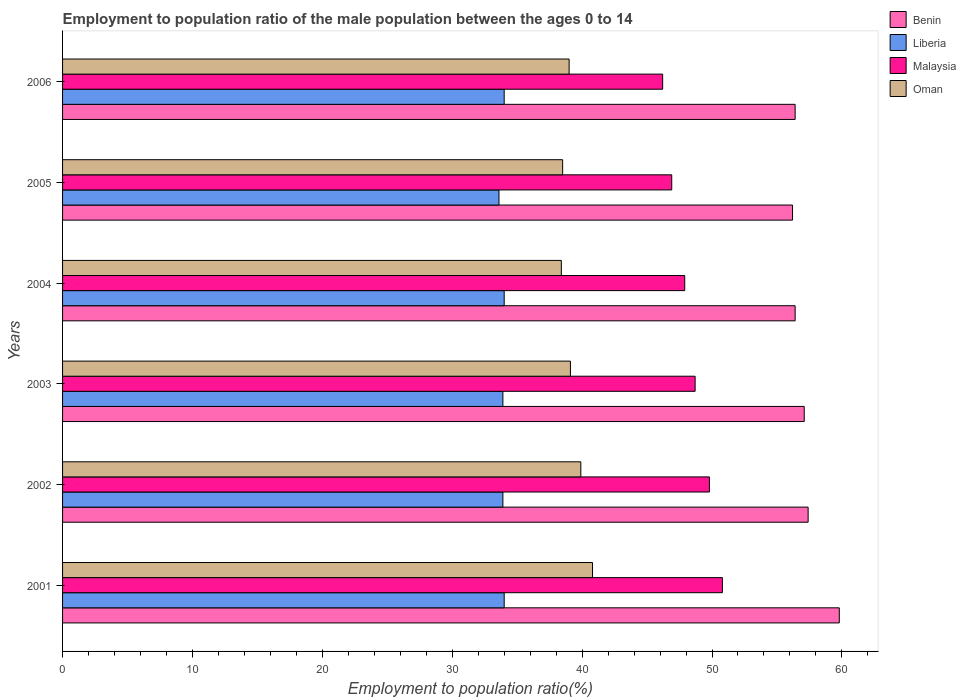How many different coloured bars are there?
Ensure brevity in your answer.  4. Are the number of bars on each tick of the Y-axis equal?
Ensure brevity in your answer.  Yes. In how many cases, is the number of bars for a given year not equal to the number of legend labels?
Give a very brief answer. 0. What is the employment to population ratio in Malaysia in 2001?
Offer a very short reply. 50.8. Across all years, what is the maximum employment to population ratio in Benin?
Keep it short and to the point. 59.8. Across all years, what is the minimum employment to population ratio in Malaysia?
Offer a very short reply. 46.2. In which year was the employment to population ratio in Malaysia maximum?
Provide a short and direct response. 2001. What is the total employment to population ratio in Liberia in the graph?
Give a very brief answer. 203.4. What is the difference between the employment to population ratio in Malaysia in 2001 and that in 2004?
Provide a short and direct response. 2.9. What is the difference between the employment to population ratio in Benin in 2004 and the employment to population ratio in Oman in 2005?
Your response must be concise. 17.9. What is the average employment to population ratio in Oman per year?
Ensure brevity in your answer.  39.28. In the year 2004, what is the difference between the employment to population ratio in Malaysia and employment to population ratio in Liberia?
Offer a very short reply. 13.9. In how many years, is the employment to population ratio in Liberia greater than 54 %?
Offer a terse response. 0. What is the ratio of the employment to population ratio in Oman in 2002 to that in 2005?
Give a very brief answer. 1.04. Is the employment to population ratio in Oman in 2003 less than that in 2006?
Provide a short and direct response. No. Is the difference between the employment to population ratio in Malaysia in 2003 and 2004 greater than the difference between the employment to population ratio in Liberia in 2003 and 2004?
Ensure brevity in your answer.  Yes. What is the difference between the highest and the lowest employment to population ratio in Benin?
Keep it short and to the point. 3.6. What does the 4th bar from the top in 2004 represents?
Give a very brief answer. Benin. What does the 2nd bar from the bottom in 2005 represents?
Offer a very short reply. Liberia. How many years are there in the graph?
Offer a very short reply. 6. What is the difference between two consecutive major ticks on the X-axis?
Offer a terse response. 10. Are the values on the major ticks of X-axis written in scientific E-notation?
Offer a very short reply. No. Does the graph contain grids?
Keep it short and to the point. No. What is the title of the graph?
Ensure brevity in your answer.  Employment to population ratio of the male population between the ages 0 to 14. What is the Employment to population ratio(%) of Benin in 2001?
Offer a terse response. 59.8. What is the Employment to population ratio(%) of Liberia in 2001?
Give a very brief answer. 34. What is the Employment to population ratio(%) of Malaysia in 2001?
Keep it short and to the point. 50.8. What is the Employment to population ratio(%) in Oman in 2001?
Provide a short and direct response. 40.8. What is the Employment to population ratio(%) of Benin in 2002?
Offer a terse response. 57.4. What is the Employment to population ratio(%) in Liberia in 2002?
Provide a succinct answer. 33.9. What is the Employment to population ratio(%) of Malaysia in 2002?
Provide a short and direct response. 49.8. What is the Employment to population ratio(%) of Oman in 2002?
Your response must be concise. 39.9. What is the Employment to population ratio(%) in Benin in 2003?
Keep it short and to the point. 57.1. What is the Employment to population ratio(%) of Liberia in 2003?
Provide a short and direct response. 33.9. What is the Employment to population ratio(%) in Malaysia in 2003?
Keep it short and to the point. 48.7. What is the Employment to population ratio(%) in Oman in 2003?
Offer a terse response. 39.1. What is the Employment to population ratio(%) in Benin in 2004?
Ensure brevity in your answer.  56.4. What is the Employment to population ratio(%) of Liberia in 2004?
Your response must be concise. 34. What is the Employment to population ratio(%) of Malaysia in 2004?
Make the answer very short. 47.9. What is the Employment to population ratio(%) in Oman in 2004?
Provide a succinct answer. 38.4. What is the Employment to population ratio(%) in Benin in 2005?
Your answer should be compact. 56.2. What is the Employment to population ratio(%) in Liberia in 2005?
Make the answer very short. 33.6. What is the Employment to population ratio(%) in Malaysia in 2005?
Keep it short and to the point. 46.9. What is the Employment to population ratio(%) of Oman in 2005?
Provide a succinct answer. 38.5. What is the Employment to population ratio(%) of Benin in 2006?
Provide a short and direct response. 56.4. What is the Employment to population ratio(%) in Malaysia in 2006?
Ensure brevity in your answer.  46.2. What is the Employment to population ratio(%) of Oman in 2006?
Provide a succinct answer. 39. Across all years, what is the maximum Employment to population ratio(%) in Benin?
Offer a terse response. 59.8. Across all years, what is the maximum Employment to population ratio(%) in Liberia?
Give a very brief answer. 34. Across all years, what is the maximum Employment to population ratio(%) of Malaysia?
Make the answer very short. 50.8. Across all years, what is the maximum Employment to population ratio(%) of Oman?
Make the answer very short. 40.8. Across all years, what is the minimum Employment to population ratio(%) of Benin?
Offer a very short reply. 56.2. Across all years, what is the minimum Employment to population ratio(%) in Liberia?
Keep it short and to the point. 33.6. Across all years, what is the minimum Employment to population ratio(%) of Malaysia?
Keep it short and to the point. 46.2. Across all years, what is the minimum Employment to population ratio(%) in Oman?
Your answer should be very brief. 38.4. What is the total Employment to population ratio(%) of Benin in the graph?
Offer a terse response. 343.3. What is the total Employment to population ratio(%) in Liberia in the graph?
Provide a short and direct response. 203.4. What is the total Employment to population ratio(%) of Malaysia in the graph?
Your answer should be compact. 290.3. What is the total Employment to population ratio(%) in Oman in the graph?
Offer a terse response. 235.7. What is the difference between the Employment to population ratio(%) in Benin in 2001 and that in 2002?
Offer a very short reply. 2.4. What is the difference between the Employment to population ratio(%) in Liberia in 2001 and that in 2002?
Offer a terse response. 0.1. What is the difference between the Employment to population ratio(%) of Oman in 2001 and that in 2002?
Your answer should be very brief. 0.9. What is the difference between the Employment to population ratio(%) in Benin in 2001 and that in 2003?
Offer a very short reply. 2.7. What is the difference between the Employment to population ratio(%) in Liberia in 2001 and that in 2003?
Provide a succinct answer. 0.1. What is the difference between the Employment to population ratio(%) of Malaysia in 2001 and that in 2003?
Your answer should be compact. 2.1. What is the difference between the Employment to population ratio(%) in Oman in 2001 and that in 2003?
Keep it short and to the point. 1.7. What is the difference between the Employment to population ratio(%) in Liberia in 2001 and that in 2004?
Offer a very short reply. 0. What is the difference between the Employment to population ratio(%) of Oman in 2001 and that in 2004?
Offer a terse response. 2.4. What is the difference between the Employment to population ratio(%) in Benin in 2001 and that in 2005?
Your response must be concise. 3.6. What is the difference between the Employment to population ratio(%) of Oman in 2001 and that in 2006?
Offer a very short reply. 1.8. What is the difference between the Employment to population ratio(%) of Malaysia in 2002 and that in 2003?
Provide a short and direct response. 1.1. What is the difference between the Employment to population ratio(%) of Oman in 2002 and that in 2003?
Make the answer very short. 0.8. What is the difference between the Employment to population ratio(%) of Benin in 2002 and that in 2004?
Give a very brief answer. 1. What is the difference between the Employment to population ratio(%) of Malaysia in 2002 and that in 2004?
Keep it short and to the point. 1.9. What is the difference between the Employment to population ratio(%) in Oman in 2002 and that in 2004?
Keep it short and to the point. 1.5. What is the difference between the Employment to population ratio(%) in Benin in 2002 and that in 2005?
Your response must be concise. 1.2. What is the difference between the Employment to population ratio(%) of Malaysia in 2002 and that in 2005?
Make the answer very short. 2.9. What is the difference between the Employment to population ratio(%) of Liberia in 2002 and that in 2006?
Provide a short and direct response. -0.1. What is the difference between the Employment to population ratio(%) in Malaysia in 2002 and that in 2006?
Offer a very short reply. 3.6. What is the difference between the Employment to population ratio(%) of Oman in 2003 and that in 2005?
Provide a succinct answer. 0.6. What is the difference between the Employment to population ratio(%) in Liberia in 2003 and that in 2006?
Keep it short and to the point. -0.1. What is the difference between the Employment to population ratio(%) in Malaysia in 2003 and that in 2006?
Provide a succinct answer. 2.5. What is the difference between the Employment to population ratio(%) in Oman in 2004 and that in 2005?
Your answer should be compact. -0.1. What is the difference between the Employment to population ratio(%) in Liberia in 2005 and that in 2006?
Give a very brief answer. -0.4. What is the difference between the Employment to population ratio(%) of Benin in 2001 and the Employment to population ratio(%) of Liberia in 2002?
Make the answer very short. 25.9. What is the difference between the Employment to population ratio(%) of Liberia in 2001 and the Employment to population ratio(%) of Malaysia in 2002?
Your answer should be compact. -15.8. What is the difference between the Employment to population ratio(%) in Malaysia in 2001 and the Employment to population ratio(%) in Oman in 2002?
Provide a succinct answer. 10.9. What is the difference between the Employment to population ratio(%) of Benin in 2001 and the Employment to population ratio(%) of Liberia in 2003?
Offer a terse response. 25.9. What is the difference between the Employment to population ratio(%) in Benin in 2001 and the Employment to population ratio(%) in Malaysia in 2003?
Provide a short and direct response. 11.1. What is the difference between the Employment to population ratio(%) in Benin in 2001 and the Employment to population ratio(%) in Oman in 2003?
Your answer should be very brief. 20.7. What is the difference between the Employment to population ratio(%) of Liberia in 2001 and the Employment to population ratio(%) of Malaysia in 2003?
Ensure brevity in your answer.  -14.7. What is the difference between the Employment to population ratio(%) in Malaysia in 2001 and the Employment to population ratio(%) in Oman in 2003?
Provide a short and direct response. 11.7. What is the difference between the Employment to population ratio(%) in Benin in 2001 and the Employment to population ratio(%) in Liberia in 2004?
Offer a terse response. 25.8. What is the difference between the Employment to population ratio(%) of Benin in 2001 and the Employment to population ratio(%) of Malaysia in 2004?
Provide a succinct answer. 11.9. What is the difference between the Employment to population ratio(%) in Benin in 2001 and the Employment to population ratio(%) in Oman in 2004?
Your answer should be compact. 21.4. What is the difference between the Employment to population ratio(%) in Liberia in 2001 and the Employment to population ratio(%) in Malaysia in 2004?
Your answer should be compact. -13.9. What is the difference between the Employment to population ratio(%) of Liberia in 2001 and the Employment to population ratio(%) of Oman in 2004?
Your answer should be compact. -4.4. What is the difference between the Employment to population ratio(%) of Benin in 2001 and the Employment to population ratio(%) of Liberia in 2005?
Your answer should be very brief. 26.2. What is the difference between the Employment to population ratio(%) in Benin in 2001 and the Employment to population ratio(%) in Malaysia in 2005?
Your answer should be very brief. 12.9. What is the difference between the Employment to population ratio(%) of Benin in 2001 and the Employment to population ratio(%) of Oman in 2005?
Your answer should be compact. 21.3. What is the difference between the Employment to population ratio(%) of Liberia in 2001 and the Employment to population ratio(%) of Malaysia in 2005?
Make the answer very short. -12.9. What is the difference between the Employment to population ratio(%) in Liberia in 2001 and the Employment to population ratio(%) in Oman in 2005?
Make the answer very short. -4.5. What is the difference between the Employment to population ratio(%) in Malaysia in 2001 and the Employment to population ratio(%) in Oman in 2005?
Your answer should be very brief. 12.3. What is the difference between the Employment to population ratio(%) of Benin in 2001 and the Employment to population ratio(%) of Liberia in 2006?
Offer a terse response. 25.8. What is the difference between the Employment to population ratio(%) of Benin in 2001 and the Employment to population ratio(%) of Oman in 2006?
Your answer should be very brief. 20.8. What is the difference between the Employment to population ratio(%) of Benin in 2002 and the Employment to population ratio(%) of Malaysia in 2003?
Offer a terse response. 8.7. What is the difference between the Employment to population ratio(%) in Benin in 2002 and the Employment to population ratio(%) in Oman in 2003?
Your response must be concise. 18.3. What is the difference between the Employment to population ratio(%) in Liberia in 2002 and the Employment to population ratio(%) in Malaysia in 2003?
Offer a very short reply. -14.8. What is the difference between the Employment to population ratio(%) in Liberia in 2002 and the Employment to population ratio(%) in Oman in 2003?
Give a very brief answer. -5.2. What is the difference between the Employment to population ratio(%) of Malaysia in 2002 and the Employment to population ratio(%) of Oman in 2003?
Give a very brief answer. 10.7. What is the difference between the Employment to population ratio(%) of Benin in 2002 and the Employment to population ratio(%) of Liberia in 2004?
Ensure brevity in your answer.  23.4. What is the difference between the Employment to population ratio(%) of Benin in 2002 and the Employment to population ratio(%) of Malaysia in 2004?
Ensure brevity in your answer.  9.5. What is the difference between the Employment to population ratio(%) of Benin in 2002 and the Employment to population ratio(%) of Oman in 2004?
Give a very brief answer. 19. What is the difference between the Employment to population ratio(%) in Liberia in 2002 and the Employment to population ratio(%) in Malaysia in 2004?
Keep it short and to the point. -14. What is the difference between the Employment to population ratio(%) of Liberia in 2002 and the Employment to population ratio(%) of Oman in 2004?
Offer a terse response. -4.5. What is the difference between the Employment to population ratio(%) of Malaysia in 2002 and the Employment to population ratio(%) of Oman in 2004?
Make the answer very short. 11.4. What is the difference between the Employment to population ratio(%) in Benin in 2002 and the Employment to population ratio(%) in Liberia in 2005?
Provide a succinct answer. 23.8. What is the difference between the Employment to population ratio(%) in Liberia in 2002 and the Employment to population ratio(%) in Malaysia in 2005?
Provide a short and direct response. -13. What is the difference between the Employment to population ratio(%) of Liberia in 2002 and the Employment to population ratio(%) of Oman in 2005?
Ensure brevity in your answer.  -4.6. What is the difference between the Employment to population ratio(%) of Benin in 2002 and the Employment to population ratio(%) of Liberia in 2006?
Provide a short and direct response. 23.4. What is the difference between the Employment to population ratio(%) in Benin in 2002 and the Employment to population ratio(%) in Malaysia in 2006?
Give a very brief answer. 11.2. What is the difference between the Employment to population ratio(%) of Liberia in 2002 and the Employment to population ratio(%) of Oman in 2006?
Make the answer very short. -5.1. What is the difference between the Employment to population ratio(%) of Malaysia in 2002 and the Employment to population ratio(%) of Oman in 2006?
Provide a short and direct response. 10.8. What is the difference between the Employment to population ratio(%) in Benin in 2003 and the Employment to population ratio(%) in Liberia in 2004?
Your answer should be compact. 23.1. What is the difference between the Employment to population ratio(%) of Benin in 2003 and the Employment to population ratio(%) of Malaysia in 2004?
Ensure brevity in your answer.  9.2. What is the difference between the Employment to population ratio(%) in Benin in 2003 and the Employment to population ratio(%) in Oman in 2004?
Provide a succinct answer. 18.7. What is the difference between the Employment to population ratio(%) of Liberia in 2003 and the Employment to population ratio(%) of Malaysia in 2004?
Provide a succinct answer. -14. What is the difference between the Employment to population ratio(%) in Liberia in 2003 and the Employment to population ratio(%) in Oman in 2004?
Your answer should be very brief. -4.5. What is the difference between the Employment to population ratio(%) in Benin in 2003 and the Employment to population ratio(%) in Liberia in 2005?
Provide a succinct answer. 23.5. What is the difference between the Employment to population ratio(%) in Benin in 2003 and the Employment to population ratio(%) in Liberia in 2006?
Provide a short and direct response. 23.1. What is the difference between the Employment to population ratio(%) in Benin in 2004 and the Employment to population ratio(%) in Liberia in 2005?
Your response must be concise. 22.8. What is the difference between the Employment to population ratio(%) of Benin in 2004 and the Employment to population ratio(%) of Malaysia in 2005?
Ensure brevity in your answer.  9.5. What is the difference between the Employment to population ratio(%) of Benin in 2004 and the Employment to population ratio(%) of Oman in 2005?
Your answer should be very brief. 17.9. What is the difference between the Employment to population ratio(%) of Malaysia in 2004 and the Employment to population ratio(%) of Oman in 2005?
Provide a succinct answer. 9.4. What is the difference between the Employment to population ratio(%) of Benin in 2004 and the Employment to population ratio(%) of Liberia in 2006?
Keep it short and to the point. 22.4. What is the difference between the Employment to population ratio(%) in Benin in 2005 and the Employment to population ratio(%) in Malaysia in 2006?
Your response must be concise. 10. What is the difference between the Employment to population ratio(%) of Liberia in 2005 and the Employment to population ratio(%) of Malaysia in 2006?
Your answer should be very brief. -12.6. What is the difference between the Employment to population ratio(%) of Malaysia in 2005 and the Employment to population ratio(%) of Oman in 2006?
Offer a terse response. 7.9. What is the average Employment to population ratio(%) in Benin per year?
Give a very brief answer. 57.22. What is the average Employment to population ratio(%) of Liberia per year?
Keep it short and to the point. 33.9. What is the average Employment to population ratio(%) of Malaysia per year?
Provide a succinct answer. 48.38. What is the average Employment to population ratio(%) in Oman per year?
Provide a short and direct response. 39.28. In the year 2001, what is the difference between the Employment to population ratio(%) in Benin and Employment to population ratio(%) in Liberia?
Provide a succinct answer. 25.8. In the year 2001, what is the difference between the Employment to population ratio(%) of Benin and Employment to population ratio(%) of Malaysia?
Keep it short and to the point. 9. In the year 2001, what is the difference between the Employment to population ratio(%) in Benin and Employment to population ratio(%) in Oman?
Ensure brevity in your answer.  19. In the year 2001, what is the difference between the Employment to population ratio(%) of Liberia and Employment to population ratio(%) of Malaysia?
Provide a short and direct response. -16.8. In the year 2001, what is the difference between the Employment to population ratio(%) of Liberia and Employment to population ratio(%) of Oman?
Your answer should be compact. -6.8. In the year 2002, what is the difference between the Employment to population ratio(%) in Benin and Employment to population ratio(%) in Malaysia?
Give a very brief answer. 7.6. In the year 2002, what is the difference between the Employment to population ratio(%) in Benin and Employment to population ratio(%) in Oman?
Your answer should be compact. 17.5. In the year 2002, what is the difference between the Employment to population ratio(%) in Liberia and Employment to population ratio(%) in Malaysia?
Offer a terse response. -15.9. In the year 2002, what is the difference between the Employment to population ratio(%) in Liberia and Employment to population ratio(%) in Oman?
Make the answer very short. -6. In the year 2002, what is the difference between the Employment to population ratio(%) of Malaysia and Employment to population ratio(%) of Oman?
Your answer should be very brief. 9.9. In the year 2003, what is the difference between the Employment to population ratio(%) in Benin and Employment to population ratio(%) in Liberia?
Keep it short and to the point. 23.2. In the year 2003, what is the difference between the Employment to population ratio(%) of Liberia and Employment to population ratio(%) of Malaysia?
Ensure brevity in your answer.  -14.8. In the year 2003, what is the difference between the Employment to population ratio(%) in Liberia and Employment to population ratio(%) in Oman?
Provide a succinct answer. -5.2. In the year 2003, what is the difference between the Employment to population ratio(%) in Malaysia and Employment to population ratio(%) in Oman?
Make the answer very short. 9.6. In the year 2004, what is the difference between the Employment to population ratio(%) in Benin and Employment to population ratio(%) in Liberia?
Make the answer very short. 22.4. In the year 2004, what is the difference between the Employment to population ratio(%) in Benin and Employment to population ratio(%) in Malaysia?
Offer a terse response. 8.5. In the year 2004, what is the difference between the Employment to population ratio(%) of Liberia and Employment to population ratio(%) of Malaysia?
Provide a succinct answer. -13.9. In the year 2004, what is the difference between the Employment to population ratio(%) in Malaysia and Employment to population ratio(%) in Oman?
Offer a very short reply. 9.5. In the year 2005, what is the difference between the Employment to population ratio(%) of Benin and Employment to population ratio(%) of Liberia?
Make the answer very short. 22.6. In the year 2005, what is the difference between the Employment to population ratio(%) of Benin and Employment to population ratio(%) of Malaysia?
Offer a terse response. 9.3. In the year 2005, what is the difference between the Employment to population ratio(%) of Liberia and Employment to population ratio(%) of Malaysia?
Give a very brief answer. -13.3. In the year 2006, what is the difference between the Employment to population ratio(%) in Benin and Employment to population ratio(%) in Liberia?
Offer a very short reply. 22.4. In the year 2006, what is the difference between the Employment to population ratio(%) in Benin and Employment to population ratio(%) in Oman?
Your answer should be very brief. 17.4. In the year 2006, what is the difference between the Employment to population ratio(%) of Liberia and Employment to population ratio(%) of Oman?
Make the answer very short. -5. What is the ratio of the Employment to population ratio(%) in Benin in 2001 to that in 2002?
Your response must be concise. 1.04. What is the ratio of the Employment to population ratio(%) in Malaysia in 2001 to that in 2002?
Offer a very short reply. 1.02. What is the ratio of the Employment to population ratio(%) in Oman in 2001 to that in 2002?
Provide a succinct answer. 1.02. What is the ratio of the Employment to population ratio(%) of Benin in 2001 to that in 2003?
Provide a succinct answer. 1.05. What is the ratio of the Employment to population ratio(%) in Malaysia in 2001 to that in 2003?
Make the answer very short. 1.04. What is the ratio of the Employment to population ratio(%) of Oman in 2001 to that in 2003?
Your answer should be compact. 1.04. What is the ratio of the Employment to population ratio(%) in Benin in 2001 to that in 2004?
Your answer should be compact. 1.06. What is the ratio of the Employment to population ratio(%) of Liberia in 2001 to that in 2004?
Ensure brevity in your answer.  1. What is the ratio of the Employment to population ratio(%) in Malaysia in 2001 to that in 2004?
Keep it short and to the point. 1.06. What is the ratio of the Employment to population ratio(%) of Oman in 2001 to that in 2004?
Your response must be concise. 1.06. What is the ratio of the Employment to population ratio(%) in Benin in 2001 to that in 2005?
Keep it short and to the point. 1.06. What is the ratio of the Employment to population ratio(%) in Liberia in 2001 to that in 2005?
Your answer should be compact. 1.01. What is the ratio of the Employment to population ratio(%) in Malaysia in 2001 to that in 2005?
Give a very brief answer. 1.08. What is the ratio of the Employment to population ratio(%) in Oman in 2001 to that in 2005?
Your response must be concise. 1.06. What is the ratio of the Employment to population ratio(%) of Benin in 2001 to that in 2006?
Keep it short and to the point. 1.06. What is the ratio of the Employment to population ratio(%) in Liberia in 2001 to that in 2006?
Give a very brief answer. 1. What is the ratio of the Employment to population ratio(%) of Malaysia in 2001 to that in 2006?
Ensure brevity in your answer.  1.1. What is the ratio of the Employment to population ratio(%) of Oman in 2001 to that in 2006?
Make the answer very short. 1.05. What is the ratio of the Employment to population ratio(%) in Liberia in 2002 to that in 2003?
Offer a terse response. 1. What is the ratio of the Employment to population ratio(%) in Malaysia in 2002 to that in 2003?
Offer a very short reply. 1.02. What is the ratio of the Employment to population ratio(%) of Oman in 2002 to that in 2003?
Provide a short and direct response. 1.02. What is the ratio of the Employment to population ratio(%) of Benin in 2002 to that in 2004?
Keep it short and to the point. 1.02. What is the ratio of the Employment to population ratio(%) of Malaysia in 2002 to that in 2004?
Your answer should be compact. 1.04. What is the ratio of the Employment to population ratio(%) of Oman in 2002 to that in 2004?
Offer a very short reply. 1.04. What is the ratio of the Employment to population ratio(%) of Benin in 2002 to that in 2005?
Keep it short and to the point. 1.02. What is the ratio of the Employment to population ratio(%) in Liberia in 2002 to that in 2005?
Offer a very short reply. 1.01. What is the ratio of the Employment to population ratio(%) of Malaysia in 2002 to that in 2005?
Provide a succinct answer. 1.06. What is the ratio of the Employment to population ratio(%) in Oman in 2002 to that in 2005?
Provide a short and direct response. 1.04. What is the ratio of the Employment to population ratio(%) in Benin in 2002 to that in 2006?
Keep it short and to the point. 1.02. What is the ratio of the Employment to population ratio(%) in Liberia in 2002 to that in 2006?
Offer a terse response. 1. What is the ratio of the Employment to population ratio(%) of Malaysia in 2002 to that in 2006?
Offer a very short reply. 1.08. What is the ratio of the Employment to population ratio(%) of Oman in 2002 to that in 2006?
Offer a very short reply. 1.02. What is the ratio of the Employment to population ratio(%) of Benin in 2003 to that in 2004?
Your answer should be very brief. 1.01. What is the ratio of the Employment to population ratio(%) of Malaysia in 2003 to that in 2004?
Ensure brevity in your answer.  1.02. What is the ratio of the Employment to population ratio(%) of Oman in 2003 to that in 2004?
Offer a very short reply. 1.02. What is the ratio of the Employment to population ratio(%) of Liberia in 2003 to that in 2005?
Keep it short and to the point. 1.01. What is the ratio of the Employment to population ratio(%) of Malaysia in 2003 to that in 2005?
Offer a very short reply. 1.04. What is the ratio of the Employment to population ratio(%) of Oman in 2003 to that in 2005?
Keep it short and to the point. 1.02. What is the ratio of the Employment to population ratio(%) in Benin in 2003 to that in 2006?
Make the answer very short. 1.01. What is the ratio of the Employment to population ratio(%) in Malaysia in 2003 to that in 2006?
Offer a terse response. 1.05. What is the ratio of the Employment to population ratio(%) of Oman in 2003 to that in 2006?
Keep it short and to the point. 1. What is the ratio of the Employment to population ratio(%) of Liberia in 2004 to that in 2005?
Your answer should be compact. 1.01. What is the ratio of the Employment to population ratio(%) in Malaysia in 2004 to that in 2005?
Provide a succinct answer. 1.02. What is the ratio of the Employment to population ratio(%) in Benin in 2004 to that in 2006?
Make the answer very short. 1. What is the ratio of the Employment to population ratio(%) of Malaysia in 2004 to that in 2006?
Provide a short and direct response. 1.04. What is the ratio of the Employment to population ratio(%) of Oman in 2004 to that in 2006?
Your response must be concise. 0.98. What is the ratio of the Employment to population ratio(%) of Benin in 2005 to that in 2006?
Give a very brief answer. 1. What is the ratio of the Employment to population ratio(%) of Malaysia in 2005 to that in 2006?
Provide a succinct answer. 1.02. What is the ratio of the Employment to population ratio(%) in Oman in 2005 to that in 2006?
Your answer should be very brief. 0.99. What is the difference between the highest and the second highest Employment to population ratio(%) in Benin?
Your answer should be compact. 2.4. What is the difference between the highest and the lowest Employment to population ratio(%) in Benin?
Offer a terse response. 3.6. What is the difference between the highest and the lowest Employment to population ratio(%) in Liberia?
Offer a terse response. 0.4. What is the difference between the highest and the lowest Employment to population ratio(%) of Malaysia?
Ensure brevity in your answer.  4.6. 